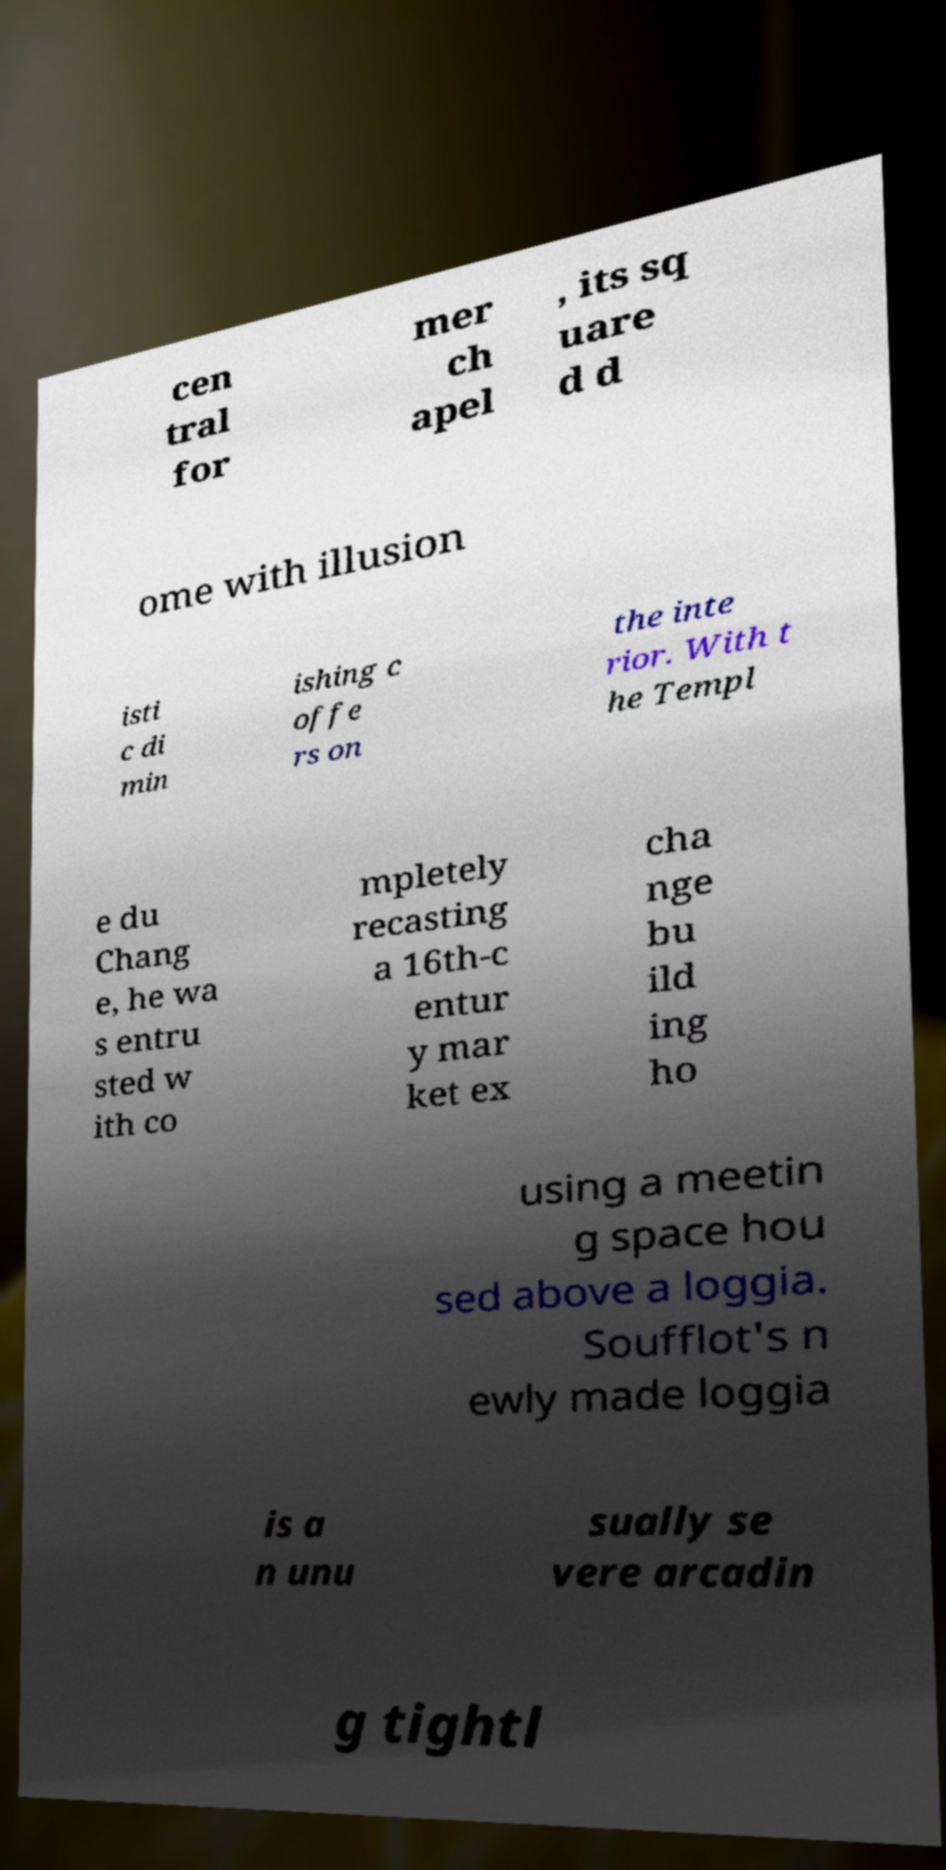Can you read and provide the text displayed in the image?This photo seems to have some interesting text. Can you extract and type it out for me? cen tral for mer ch apel , its sq uare d d ome with illusion isti c di min ishing c offe rs on the inte rior. With t he Templ e du Chang e, he wa s entru sted w ith co mpletely recasting a 16th-c entur y mar ket ex cha nge bu ild ing ho using a meetin g space hou sed above a loggia. Soufflot's n ewly made loggia is a n unu sually se vere arcadin g tightl 